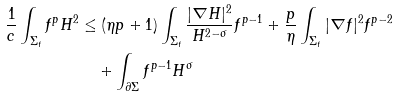Convert formula to latex. <formula><loc_0><loc_0><loc_500><loc_500>\frac { 1 } { c } \int _ { \Sigma _ { t } } f ^ { p } H ^ { 2 } & \leq ( \eta p + 1 ) \int _ { \Sigma _ { t } } \frac { | \nabla H | ^ { 2 } } { H ^ { 2 - \sigma } } f ^ { p - 1 } + \frac { p } { \eta } \int _ { \Sigma _ { t } } | \nabla f | ^ { 2 } f ^ { p - 2 } \\ & \quad + \int _ { \partial \Sigma } f ^ { p - 1 } H ^ { \sigma }</formula> 